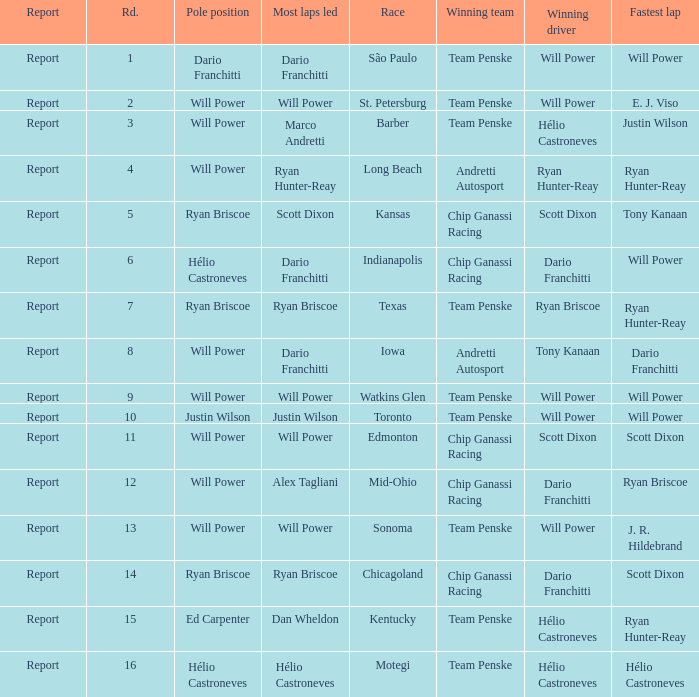In what position did the winning driver finish at Chicagoland? 1.0. 